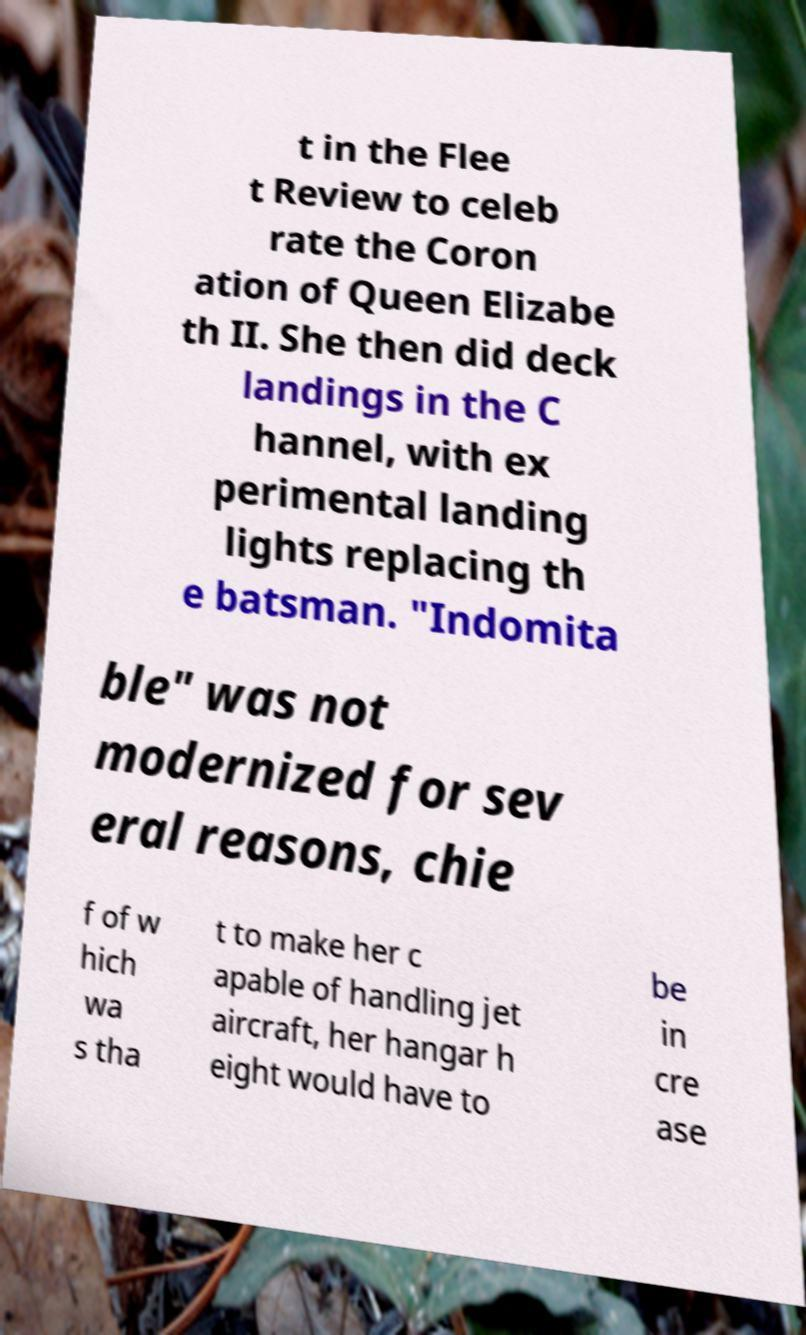Please read and relay the text visible in this image. What does it say? t in the Flee t Review to celeb rate the Coron ation of Queen Elizabe th II. She then did deck landings in the C hannel, with ex perimental landing lights replacing th e batsman. "Indomita ble" was not modernized for sev eral reasons, chie f of w hich wa s tha t to make her c apable of handling jet aircraft, her hangar h eight would have to be in cre ase 